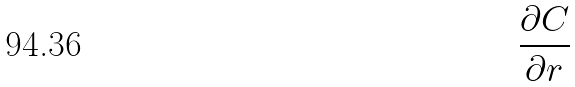Convert formula to latex. <formula><loc_0><loc_0><loc_500><loc_500>\frac { \partial C } { \partial r }</formula> 